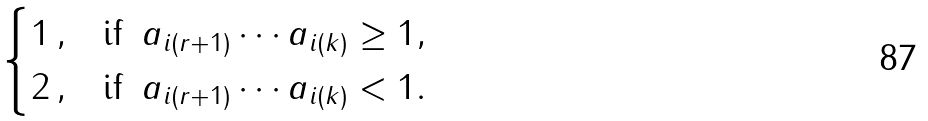Convert formula to latex. <formula><loc_0><loc_0><loc_500><loc_500>\begin{cases} 1 \, , & \text {if } \, a _ { i ( r + 1 ) } \cdots a _ { i ( k ) } \geq 1 , \\ 2 \, , & \text {if } \, a _ { i ( r + 1 ) } \cdots a _ { i ( k ) } < 1 . \end{cases}</formula> 